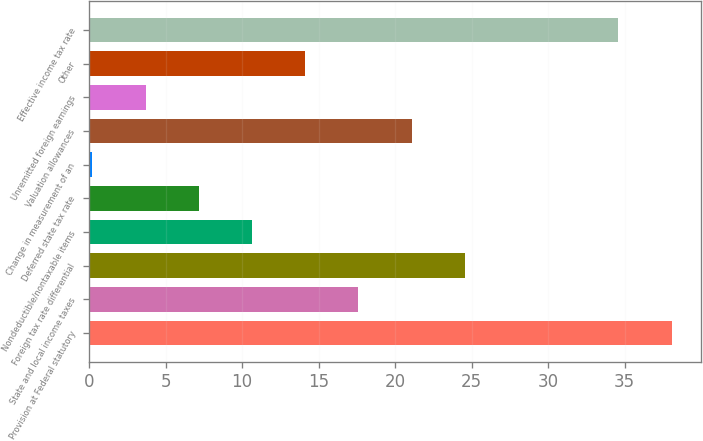<chart> <loc_0><loc_0><loc_500><loc_500><bar_chart><fcel>Provision at Federal statutory<fcel>State and local income taxes<fcel>Foreign tax rate differential<fcel>Nondeductible/nontaxable items<fcel>Deferred state tax rate<fcel>Change in measurement of an<fcel>Valuation allowances<fcel>Unremitted foreign earnings<fcel>Other<fcel>Effective income tax rate<nl><fcel>38.08<fcel>17.61<fcel>24.57<fcel>10.65<fcel>7.17<fcel>0.21<fcel>21.09<fcel>3.69<fcel>14.13<fcel>34.6<nl></chart> 